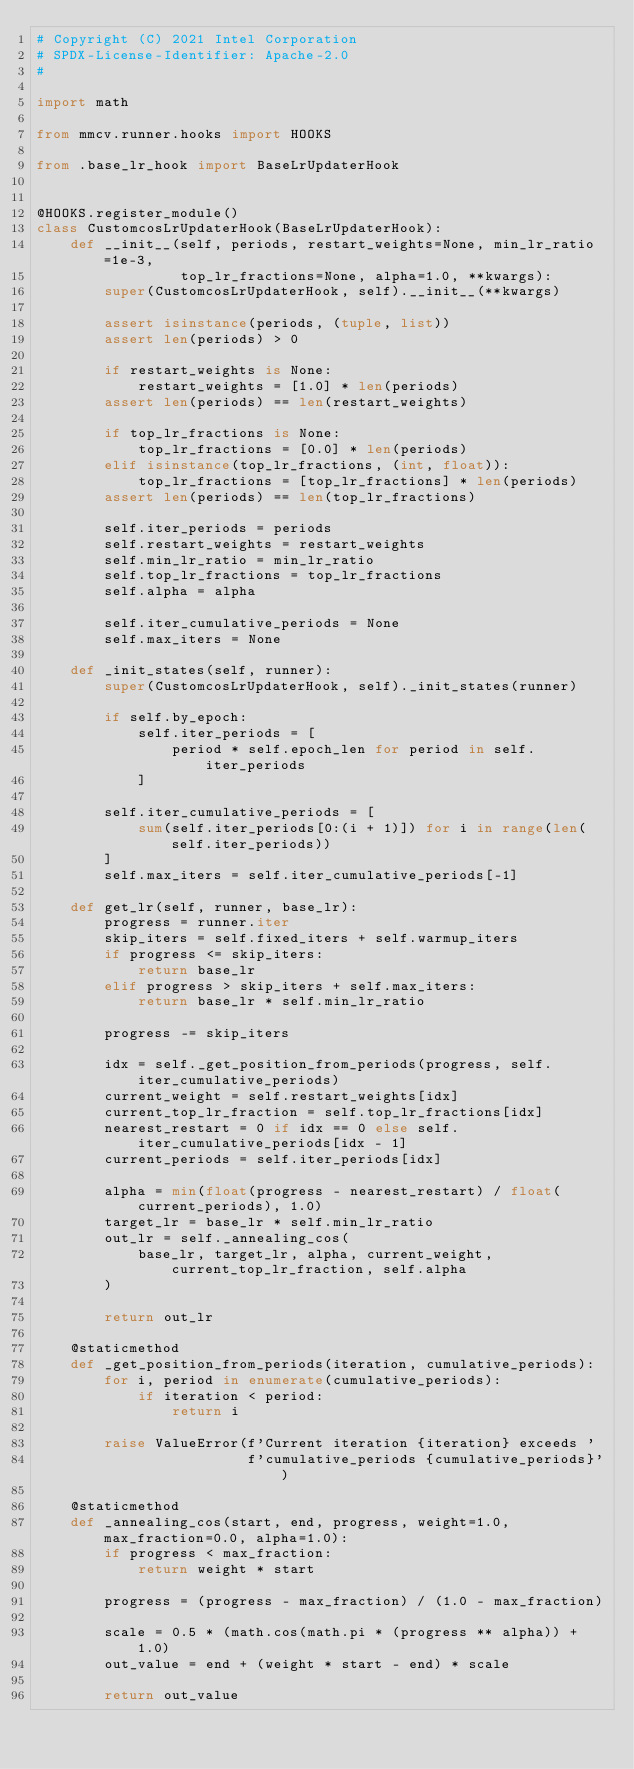<code> <loc_0><loc_0><loc_500><loc_500><_Python_># Copyright (C) 2021 Intel Corporation
# SPDX-License-Identifier: Apache-2.0
#

import math

from mmcv.runner.hooks import HOOKS

from .base_lr_hook import BaseLrUpdaterHook


@HOOKS.register_module()
class CustomcosLrUpdaterHook(BaseLrUpdaterHook):
    def __init__(self, periods, restart_weights=None, min_lr_ratio=1e-3,
                 top_lr_fractions=None, alpha=1.0, **kwargs):
        super(CustomcosLrUpdaterHook, self).__init__(**kwargs)

        assert isinstance(periods, (tuple, list))
        assert len(periods) > 0

        if restart_weights is None:
            restart_weights = [1.0] * len(periods)
        assert len(periods) == len(restart_weights)

        if top_lr_fractions is None:
            top_lr_fractions = [0.0] * len(periods)
        elif isinstance(top_lr_fractions, (int, float)):
            top_lr_fractions = [top_lr_fractions] * len(periods)
        assert len(periods) == len(top_lr_fractions)

        self.iter_periods = periods
        self.restart_weights = restart_weights
        self.min_lr_ratio = min_lr_ratio
        self.top_lr_fractions = top_lr_fractions
        self.alpha = alpha

        self.iter_cumulative_periods = None
        self.max_iters = None

    def _init_states(self, runner):
        super(CustomcosLrUpdaterHook, self)._init_states(runner)

        if self.by_epoch:
            self.iter_periods = [
                period * self.epoch_len for period in self.iter_periods
            ]

        self.iter_cumulative_periods = [
            sum(self.iter_periods[0:(i + 1)]) for i in range(len(self.iter_periods))
        ]
        self.max_iters = self.iter_cumulative_periods[-1]

    def get_lr(self, runner, base_lr):
        progress = runner.iter
        skip_iters = self.fixed_iters + self.warmup_iters
        if progress <= skip_iters:
            return base_lr
        elif progress > skip_iters + self.max_iters:
            return base_lr * self.min_lr_ratio

        progress -= skip_iters

        idx = self._get_position_from_periods(progress, self.iter_cumulative_periods)
        current_weight = self.restart_weights[idx]
        current_top_lr_fraction = self.top_lr_fractions[idx]
        nearest_restart = 0 if idx == 0 else self.iter_cumulative_periods[idx - 1]
        current_periods = self.iter_periods[idx]

        alpha = min(float(progress - nearest_restart) / float(current_periods), 1.0)
        target_lr = base_lr * self.min_lr_ratio
        out_lr = self._annealing_cos(
            base_lr, target_lr, alpha, current_weight, current_top_lr_fraction, self.alpha
        )

        return out_lr

    @staticmethod
    def _get_position_from_periods(iteration, cumulative_periods):
        for i, period in enumerate(cumulative_periods):
            if iteration < period:
                return i

        raise ValueError(f'Current iteration {iteration} exceeds '
                         f'cumulative_periods {cumulative_periods}')

    @staticmethod
    def _annealing_cos(start, end, progress, weight=1.0, max_fraction=0.0, alpha=1.0):
        if progress < max_fraction:
            return weight * start

        progress = (progress - max_fraction) / (1.0 - max_fraction)

        scale = 0.5 * (math.cos(math.pi * (progress ** alpha)) + 1.0)
        out_value = end + (weight * start - end) * scale

        return out_value
</code> 